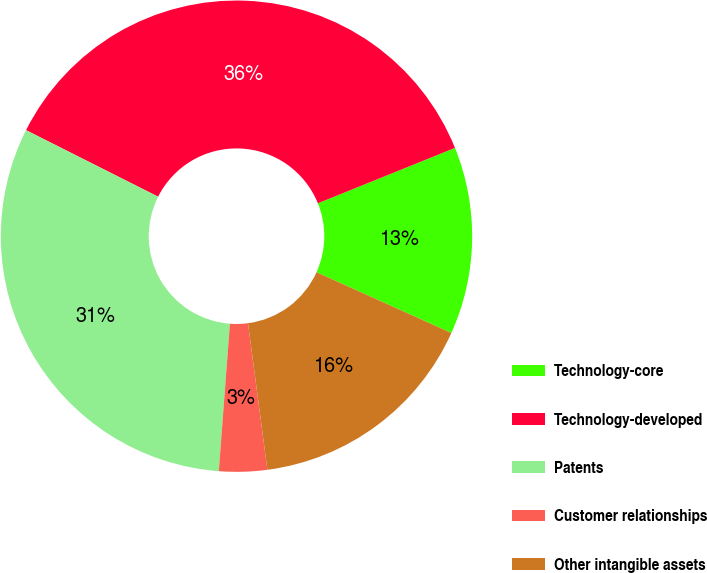Convert chart. <chart><loc_0><loc_0><loc_500><loc_500><pie_chart><fcel>Technology-core<fcel>Technology-developed<fcel>Patents<fcel>Customer relationships<fcel>Other intangible assets<nl><fcel>12.85%<fcel>36.46%<fcel>31.23%<fcel>3.29%<fcel>16.17%<nl></chart> 